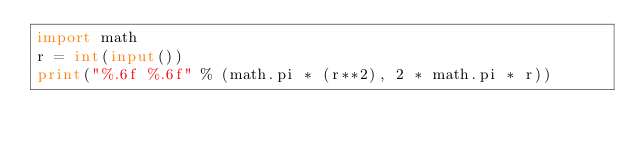<code> <loc_0><loc_0><loc_500><loc_500><_Python_>import math
r = int(input())
print("%.6f %.6f" % (math.pi * (r**2), 2 * math.pi * r))</code> 